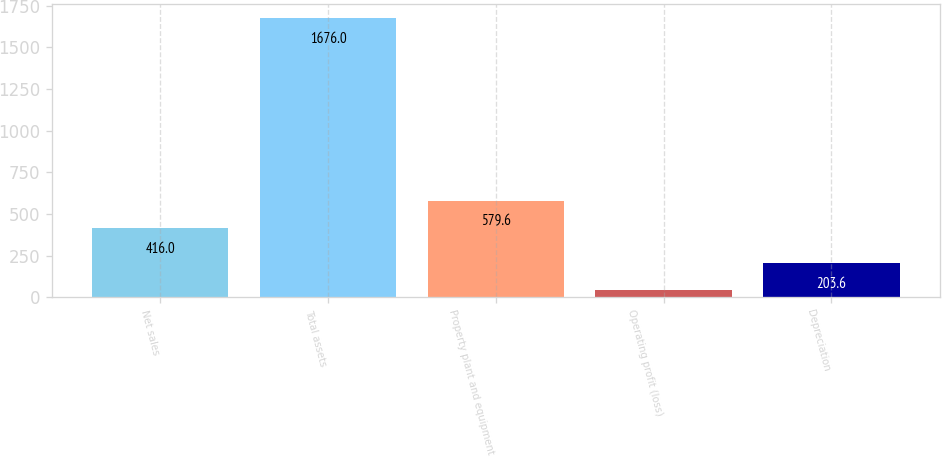<chart> <loc_0><loc_0><loc_500><loc_500><bar_chart><fcel>Net sales<fcel>Total assets<fcel>Property plant and equipment<fcel>Operating profit (loss)<fcel>Depreciation<nl><fcel>416<fcel>1676<fcel>579.6<fcel>40<fcel>203.6<nl></chart> 